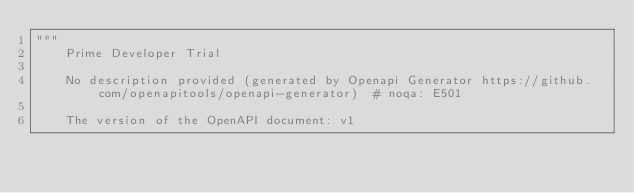<code> <loc_0><loc_0><loc_500><loc_500><_Python_>"""
    Prime Developer Trial

    No description provided (generated by Openapi Generator https://github.com/openapitools/openapi-generator)  # noqa: E501

    The version of the OpenAPI document: v1</code> 